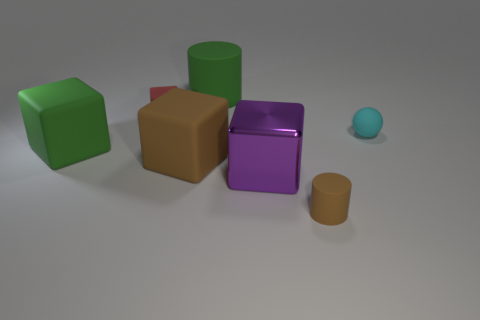Subtract all rubber cubes. How many cubes are left? 1 Subtract 1 cubes. How many cubes are left? 3 Add 2 big cubes. How many objects exist? 9 Subtract all green cubes. How many cubes are left? 3 Subtract all balls. How many objects are left? 6 Subtract all yellow cylinders. Subtract all green blocks. How many cylinders are left? 2 Subtract all cylinders. Subtract all small cyan balls. How many objects are left? 4 Add 3 big purple cubes. How many big purple cubes are left? 4 Add 1 big green metallic objects. How many big green metallic objects exist? 1 Subtract 0 yellow balls. How many objects are left? 7 